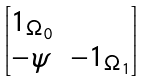Convert formula to latex. <formula><loc_0><loc_0><loc_500><loc_500>\begin{bmatrix} 1 _ { \Omega _ { 0 } } & \\ - \psi & - 1 _ { \Omega _ { 1 } } \end{bmatrix}</formula> 